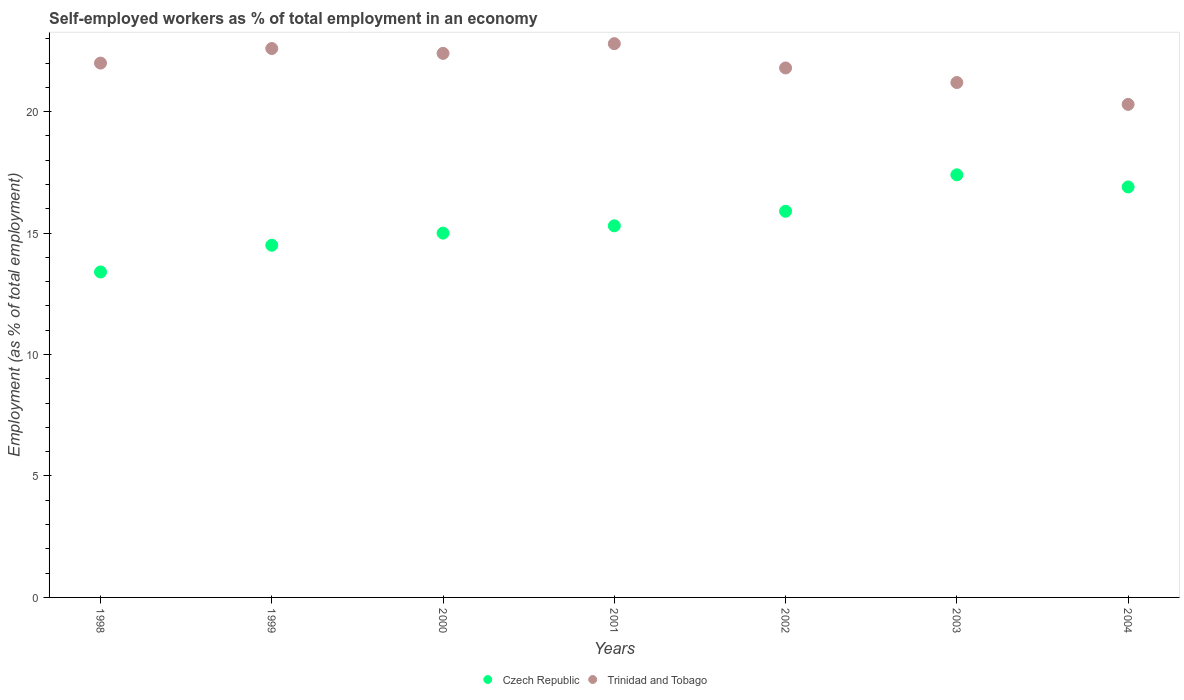How many different coloured dotlines are there?
Your answer should be very brief. 2. Is the number of dotlines equal to the number of legend labels?
Your response must be concise. Yes. What is the percentage of self-employed workers in Czech Republic in 1998?
Provide a succinct answer. 13.4. Across all years, what is the maximum percentage of self-employed workers in Czech Republic?
Give a very brief answer. 17.4. Across all years, what is the minimum percentage of self-employed workers in Trinidad and Tobago?
Make the answer very short. 20.3. In which year was the percentage of self-employed workers in Trinidad and Tobago minimum?
Your answer should be very brief. 2004. What is the total percentage of self-employed workers in Czech Republic in the graph?
Ensure brevity in your answer.  108.4. What is the difference between the percentage of self-employed workers in Czech Republic in 2001 and that in 2002?
Offer a terse response. -0.6. What is the difference between the percentage of self-employed workers in Trinidad and Tobago in 2003 and the percentage of self-employed workers in Czech Republic in 2001?
Ensure brevity in your answer.  5.9. What is the average percentage of self-employed workers in Czech Republic per year?
Your answer should be very brief. 15.49. In the year 2003, what is the difference between the percentage of self-employed workers in Czech Republic and percentage of self-employed workers in Trinidad and Tobago?
Offer a terse response. -3.8. What is the ratio of the percentage of self-employed workers in Trinidad and Tobago in 1998 to that in 2002?
Your response must be concise. 1.01. Is the percentage of self-employed workers in Czech Republic in 1998 less than that in 2002?
Provide a short and direct response. Yes. What is the difference between the highest and the second highest percentage of self-employed workers in Czech Republic?
Provide a short and direct response. 0.5. Is the sum of the percentage of self-employed workers in Czech Republic in 2002 and 2004 greater than the maximum percentage of self-employed workers in Trinidad and Tobago across all years?
Provide a succinct answer. Yes. Does the percentage of self-employed workers in Czech Republic monotonically increase over the years?
Ensure brevity in your answer.  No. Is the percentage of self-employed workers in Czech Republic strictly greater than the percentage of self-employed workers in Trinidad and Tobago over the years?
Your answer should be very brief. No. Is the percentage of self-employed workers in Czech Republic strictly less than the percentage of self-employed workers in Trinidad and Tobago over the years?
Your response must be concise. Yes. Are the values on the major ticks of Y-axis written in scientific E-notation?
Ensure brevity in your answer.  No. Does the graph contain any zero values?
Provide a short and direct response. No. Does the graph contain grids?
Your response must be concise. No. Where does the legend appear in the graph?
Ensure brevity in your answer.  Bottom center. How are the legend labels stacked?
Provide a short and direct response. Horizontal. What is the title of the graph?
Give a very brief answer. Self-employed workers as % of total employment in an economy. Does "Guam" appear as one of the legend labels in the graph?
Your answer should be very brief. No. What is the label or title of the X-axis?
Provide a short and direct response. Years. What is the label or title of the Y-axis?
Ensure brevity in your answer.  Employment (as % of total employment). What is the Employment (as % of total employment) of Czech Republic in 1998?
Provide a succinct answer. 13.4. What is the Employment (as % of total employment) of Czech Republic in 1999?
Your response must be concise. 14.5. What is the Employment (as % of total employment) in Trinidad and Tobago in 1999?
Offer a very short reply. 22.6. What is the Employment (as % of total employment) in Trinidad and Tobago in 2000?
Give a very brief answer. 22.4. What is the Employment (as % of total employment) of Czech Republic in 2001?
Your response must be concise. 15.3. What is the Employment (as % of total employment) in Trinidad and Tobago in 2001?
Your response must be concise. 22.8. What is the Employment (as % of total employment) of Czech Republic in 2002?
Keep it short and to the point. 15.9. What is the Employment (as % of total employment) of Trinidad and Tobago in 2002?
Provide a succinct answer. 21.8. What is the Employment (as % of total employment) in Czech Republic in 2003?
Offer a terse response. 17.4. What is the Employment (as % of total employment) in Trinidad and Tobago in 2003?
Keep it short and to the point. 21.2. What is the Employment (as % of total employment) of Czech Republic in 2004?
Offer a terse response. 16.9. What is the Employment (as % of total employment) in Trinidad and Tobago in 2004?
Your answer should be compact. 20.3. Across all years, what is the maximum Employment (as % of total employment) of Czech Republic?
Keep it short and to the point. 17.4. Across all years, what is the maximum Employment (as % of total employment) of Trinidad and Tobago?
Offer a very short reply. 22.8. Across all years, what is the minimum Employment (as % of total employment) of Czech Republic?
Your answer should be compact. 13.4. Across all years, what is the minimum Employment (as % of total employment) in Trinidad and Tobago?
Offer a very short reply. 20.3. What is the total Employment (as % of total employment) of Czech Republic in the graph?
Keep it short and to the point. 108.4. What is the total Employment (as % of total employment) of Trinidad and Tobago in the graph?
Make the answer very short. 153.1. What is the difference between the Employment (as % of total employment) of Czech Republic in 1998 and that in 1999?
Your response must be concise. -1.1. What is the difference between the Employment (as % of total employment) of Trinidad and Tobago in 1998 and that in 1999?
Your answer should be very brief. -0.6. What is the difference between the Employment (as % of total employment) of Czech Republic in 1998 and that in 2000?
Provide a succinct answer. -1.6. What is the difference between the Employment (as % of total employment) in Trinidad and Tobago in 1998 and that in 2001?
Provide a succinct answer. -0.8. What is the difference between the Employment (as % of total employment) in Trinidad and Tobago in 1998 and that in 2002?
Provide a short and direct response. 0.2. What is the difference between the Employment (as % of total employment) of Czech Republic in 1998 and that in 2003?
Your response must be concise. -4. What is the difference between the Employment (as % of total employment) of Trinidad and Tobago in 1998 and that in 2004?
Give a very brief answer. 1.7. What is the difference between the Employment (as % of total employment) of Czech Republic in 1999 and that in 2001?
Keep it short and to the point. -0.8. What is the difference between the Employment (as % of total employment) in Trinidad and Tobago in 1999 and that in 2001?
Ensure brevity in your answer.  -0.2. What is the difference between the Employment (as % of total employment) in Czech Republic in 1999 and that in 2002?
Offer a terse response. -1.4. What is the difference between the Employment (as % of total employment) of Trinidad and Tobago in 1999 and that in 2002?
Keep it short and to the point. 0.8. What is the difference between the Employment (as % of total employment) of Czech Republic in 1999 and that in 2003?
Your response must be concise. -2.9. What is the difference between the Employment (as % of total employment) of Czech Republic in 1999 and that in 2004?
Provide a succinct answer. -2.4. What is the difference between the Employment (as % of total employment) of Trinidad and Tobago in 1999 and that in 2004?
Make the answer very short. 2.3. What is the difference between the Employment (as % of total employment) in Trinidad and Tobago in 2000 and that in 2001?
Make the answer very short. -0.4. What is the difference between the Employment (as % of total employment) of Czech Republic in 2000 and that in 2002?
Provide a short and direct response. -0.9. What is the difference between the Employment (as % of total employment) in Czech Republic in 2000 and that in 2003?
Provide a short and direct response. -2.4. What is the difference between the Employment (as % of total employment) in Trinidad and Tobago in 2000 and that in 2003?
Your answer should be compact. 1.2. What is the difference between the Employment (as % of total employment) in Czech Republic in 2000 and that in 2004?
Keep it short and to the point. -1.9. What is the difference between the Employment (as % of total employment) of Trinidad and Tobago in 2000 and that in 2004?
Provide a short and direct response. 2.1. What is the difference between the Employment (as % of total employment) of Trinidad and Tobago in 2001 and that in 2002?
Offer a terse response. 1. What is the difference between the Employment (as % of total employment) in Czech Republic in 2001 and that in 2004?
Your answer should be compact. -1.6. What is the difference between the Employment (as % of total employment) of Trinidad and Tobago in 2001 and that in 2004?
Ensure brevity in your answer.  2.5. What is the difference between the Employment (as % of total employment) in Trinidad and Tobago in 2003 and that in 2004?
Ensure brevity in your answer.  0.9. What is the difference between the Employment (as % of total employment) of Czech Republic in 1998 and the Employment (as % of total employment) of Trinidad and Tobago in 2000?
Your answer should be very brief. -9. What is the difference between the Employment (as % of total employment) in Czech Republic in 1998 and the Employment (as % of total employment) in Trinidad and Tobago in 2001?
Your response must be concise. -9.4. What is the difference between the Employment (as % of total employment) of Czech Republic in 1998 and the Employment (as % of total employment) of Trinidad and Tobago in 2002?
Your answer should be compact. -8.4. What is the difference between the Employment (as % of total employment) in Czech Republic in 1998 and the Employment (as % of total employment) in Trinidad and Tobago in 2003?
Offer a terse response. -7.8. What is the difference between the Employment (as % of total employment) of Czech Republic in 1999 and the Employment (as % of total employment) of Trinidad and Tobago in 2001?
Provide a succinct answer. -8.3. What is the difference between the Employment (as % of total employment) in Czech Republic in 1999 and the Employment (as % of total employment) in Trinidad and Tobago in 2004?
Give a very brief answer. -5.8. What is the difference between the Employment (as % of total employment) in Czech Republic in 2000 and the Employment (as % of total employment) in Trinidad and Tobago in 2002?
Your answer should be compact. -6.8. What is the difference between the Employment (as % of total employment) of Czech Republic in 2000 and the Employment (as % of total employment) of Trinidad and Tobago in 2004?
Offer a very short reply. -5.3. What is the difference between the Employment (as % of total employment) in Czech Republic in 2001 and the Employment (as % of total employment) in Trinidad and Tobago in 2002?
Provide a short and direct response. -6.5. What is the difference between the Employment (as % of total employment) of Czech Republic in 2001 and the Employment (as % of total employment) of Trinidad and Tobago in 2003?
Provide a short and direct response. -5.9. What is the difference between the Employment (as % of total employment) of Czech Republic in 2002 and the Employment (as % of total employment) of Trinidad and Tobago in 2004?
Provide a short and direct response. -4.4. What is the difference between the Employment (as % of total employment) of Czech Republic in 2003 and the Employment (as % of total employment) of Trinidad and Tobago in 2004?
Make the answer very short. -2.9. What is the average Employment (as % of total employment) of Czech Republic per year?
Give a very brief answer. 15.49. What is the average Employment (as % of total employment) of Trinidad and Tobago per year?
Provide a short and direct response. 21.87. In the year 1999, what is the difference between the Employment (as % of total employment) of Czech Republic and Employment (as % of total employment) of Trinidad and Tobago?
Make the answer very short. -8.1. In the year 2000, what is the difference between the Employment (as % of total employment) in Czech Republic and Employment (as % of total employment) in Trinidad and Tobago?
Offer a very short reply. -7.4. In the year 2004, what is the difference between the Employment (as % of total employment) in Czech Republic and Employment (as % of total employment) in Trinidad and Tobago?
Your response must be concise. -3.4. What is the ratio of the Employment (as % of total employment) in Czech Republic in 1998 to that in 1999?
Offer a terse response. 0.92. What is the ratio of the Employment (as % of total employment) of Trinidad and Tobago in 1998 to that in 1999?
Offer a terse response. 0.97. What is the ratio of the Employment (as % of total employment) in Czech Republic in 1998 to that in 2000?
Your answer should be very brief. 0.89. What is the ratio of the Employment (as % of total employment) of Trinidad and Tobago in 1998 to that in 2000?
Provide a short and direct response. 0.98. What is the ratio of the Employment (as % of total employment) of Czech Republic in 1998 to that in 2001?
Offer a terse response. 0.88. What is the ratio of the Employment (as % of total employment) in Trinidad and Tobago in 1998 to that in 2001?
Provide a succinct answer. 0.96. What is the ratio of the Employment (as % of total employment) of Czech Republic in 1998 to that in 2002?
Ensure brevity in your answer.  0.84. What is the ratio of the Employment (as % of total employment) in Trinidad and Tobago in 1998 to that in 2002?
Your answer should be compact. 1.01. What is the ratio of the Employment (as % of total employment) of Czech Republic in 1998 to that in 2003?
Make the answer very short. 0.77. What is the ratio of the Employment (as % of total employment) of Trinidad and Tobago in 1998 to that in 2003?
Your answer should be compact. 1.04. What is the ratio of the Employment (as % of total employment) of Czech Republic in 1998 to that in 2004?
Give a very brief answer. 0.79. What is the ratio of the Employment (as % of total employment) of Trinidad and Tobago in 1998 to that in 2004?
Your response must be concise. 1.08. What is the ratio of the Employment (as % of total employment) in Czech Republic in 1999 to that in 2000?
Provide a succinct answer. 0.97. What is the ratio of the Employment (as % of total employment) of Trinidad and Tobago in 1999 to that in 2000?
Ensure brevity in your answer.  1.01. What is the ratio of the Employment (as % of total employment) in Czech Republic in 1999 to that in 2001?
Your answer should be very brief. 0.95. What is the ratio of the Employment (as % of total employment) of Trinidad and Tobago in 1999 to that in 2001?
Offer a terse response. 0.99. What is the ratio of the Employment (as % of total employment) of Czech Republic in 1999 to that in 2002?
Provide a short and direct response. 0.91. What is the ratio of the Employment (as % of total employment) in Trinidad and Tobago in 1999 to that in 2002?
Give a very brief answer. 1.04. What is the ratio of the Employment (as % of total employment) in Czech Republic in 1999 to that in 2003?
Your answer should be compact. 0.83. What is the ratio of the Employment (as % of total employment) of Trinidad and Tobago in 1999 to that in 2003?
Make the answer very short. 1.07. What is the ratio of the Employment (as % of total employment) of Czech Republic in 1999 to that in 2004?
Provide a short and direct response. 0.86. What is the ratio of the Employment (as % of total employment) of Trinidad and Tobago in 1999 to that in 2004?
Keep it short and to the point. 1.11. What is the ratio of the Employment (as % of total employment) of Czech Republic in 2000 to that in 2001?
Provide a succinct answer. 0.98. What is the ratio of the Employment (as % of total employment) in Trinidad and Tobago in 2000 to that in 2001?
Make the answer very short. 0.98. What is the ratio of the Employment (as % of total employment) of Czech Republic in 2000 to that in 2002?
Make the answer very short. 0.94. What is the ratio of the Employment (as % of total employment) in Trinidad and Tobago in 2000 to that in 2002?
Offer a very short reply. 1.03. What is the ratio of the Employment (as % of total employment) in Czech Republic in 2000 to that in 2003?
Your answer should be very brief. 0.86. What is the ratio of the Employment (as % of total employment) in Trinidad and Tobago in 2000 to that in 2003?
Keep it short and to the point. 1.06. What is the ratio of the Employment (as % of total employment) in Czech Republic in 2000 to that in 2004?
Your response must be concise. 0.89. What is the ratio of the Employment (as % of total employment) in Trinidad and Tobago in 2000 to that in 2004?
Your answer should be very brief. 1.1. What is the ratio of the Employment (as % of total employment) in Czech Republic in 2001 to that in 2002?
Make the answer very short. 0.96. What is the ratio of the Employment (as % of total employment) in Trinidad and Tobago in 2001 to that in 2002?
Make the answer very short. 1.05. What is the ratio of the Employment (as % of total employment) in Czech Republic in 2001 to that in 2003?
Ensure brevity in your answer.  0.88. What is the ratio of the Employment (as % of total employment) of Trinidad and Tobago in 2001 to that in 2003?
Ensure brevity in your answer.  1.08. What is the ratio of the Employment (as % of total employment) of Czech Republic in 2001 to that in 2004?
Your answer should be compact. 0.91. What is the ratio of the Employment (as % of total employment) in Trinidad and Tobago in 2001 to that in 2004?
Offer a very short reply. 1.12. What is the ratio of the Employment (as % of total employment) in Czech Republic in 2002 to that in 2003?
Your answer should be compact. 0.91. What is the ratio of the Employment (as % of total employment) in Trinidad and Tobago in 2002 to that in 2003?
Provide a short and direct response. 1.03. What is the ratio of the Employment (as % of total employment) in Czech Republic in 2002 to that in 2004?
Give a very brief answer. 0.94. What is the ratio of the Employment (as % of total employment) of Trinidad and Tobago in 2002 to that in 2004?
Your response must be concise. 1.07. What is the ratio of the Employment (as % of total employment) of Czech Republic in 2003 to that in 2004?
Your answer should be very brief. 1.03. What is the ratio of the Employment (as % of total employment) in Trinidad and Tobago in 2003 to that in 2004?
Offer a very short reply. 1.04. What is the difference between the highest and the second highest Employment (as % of total employment) in Trinidad and Tobago?
Provide a short and direct response. 0.2. What is the difference between the highest and the lowest Employment (as % of total employment) in Czech Republic?
Offer a terse response. 4. What is the difference between the highest and the lowest Employment (as % of total employment) in Trinidad and Tobago?
Offer a very short reply. 2.5. 